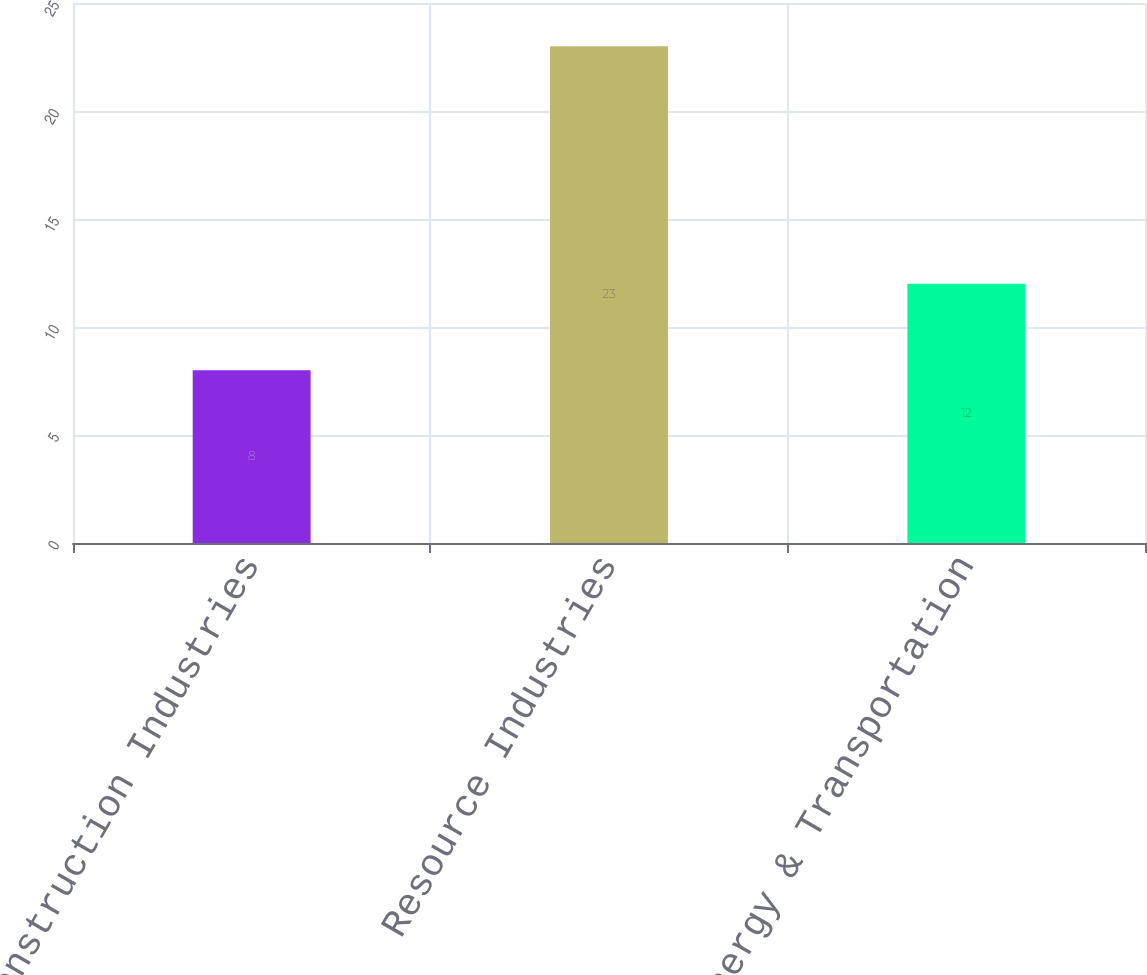Convert chart. <chart><loc_0><loc_0><loc_500><loc_500><bar_chart><fcel>Construction Industries<fcel>Resource Industries<fcel>Energy & Transportation<nl><fcel>8<fcel>23<fcel>12<nl></chart> 